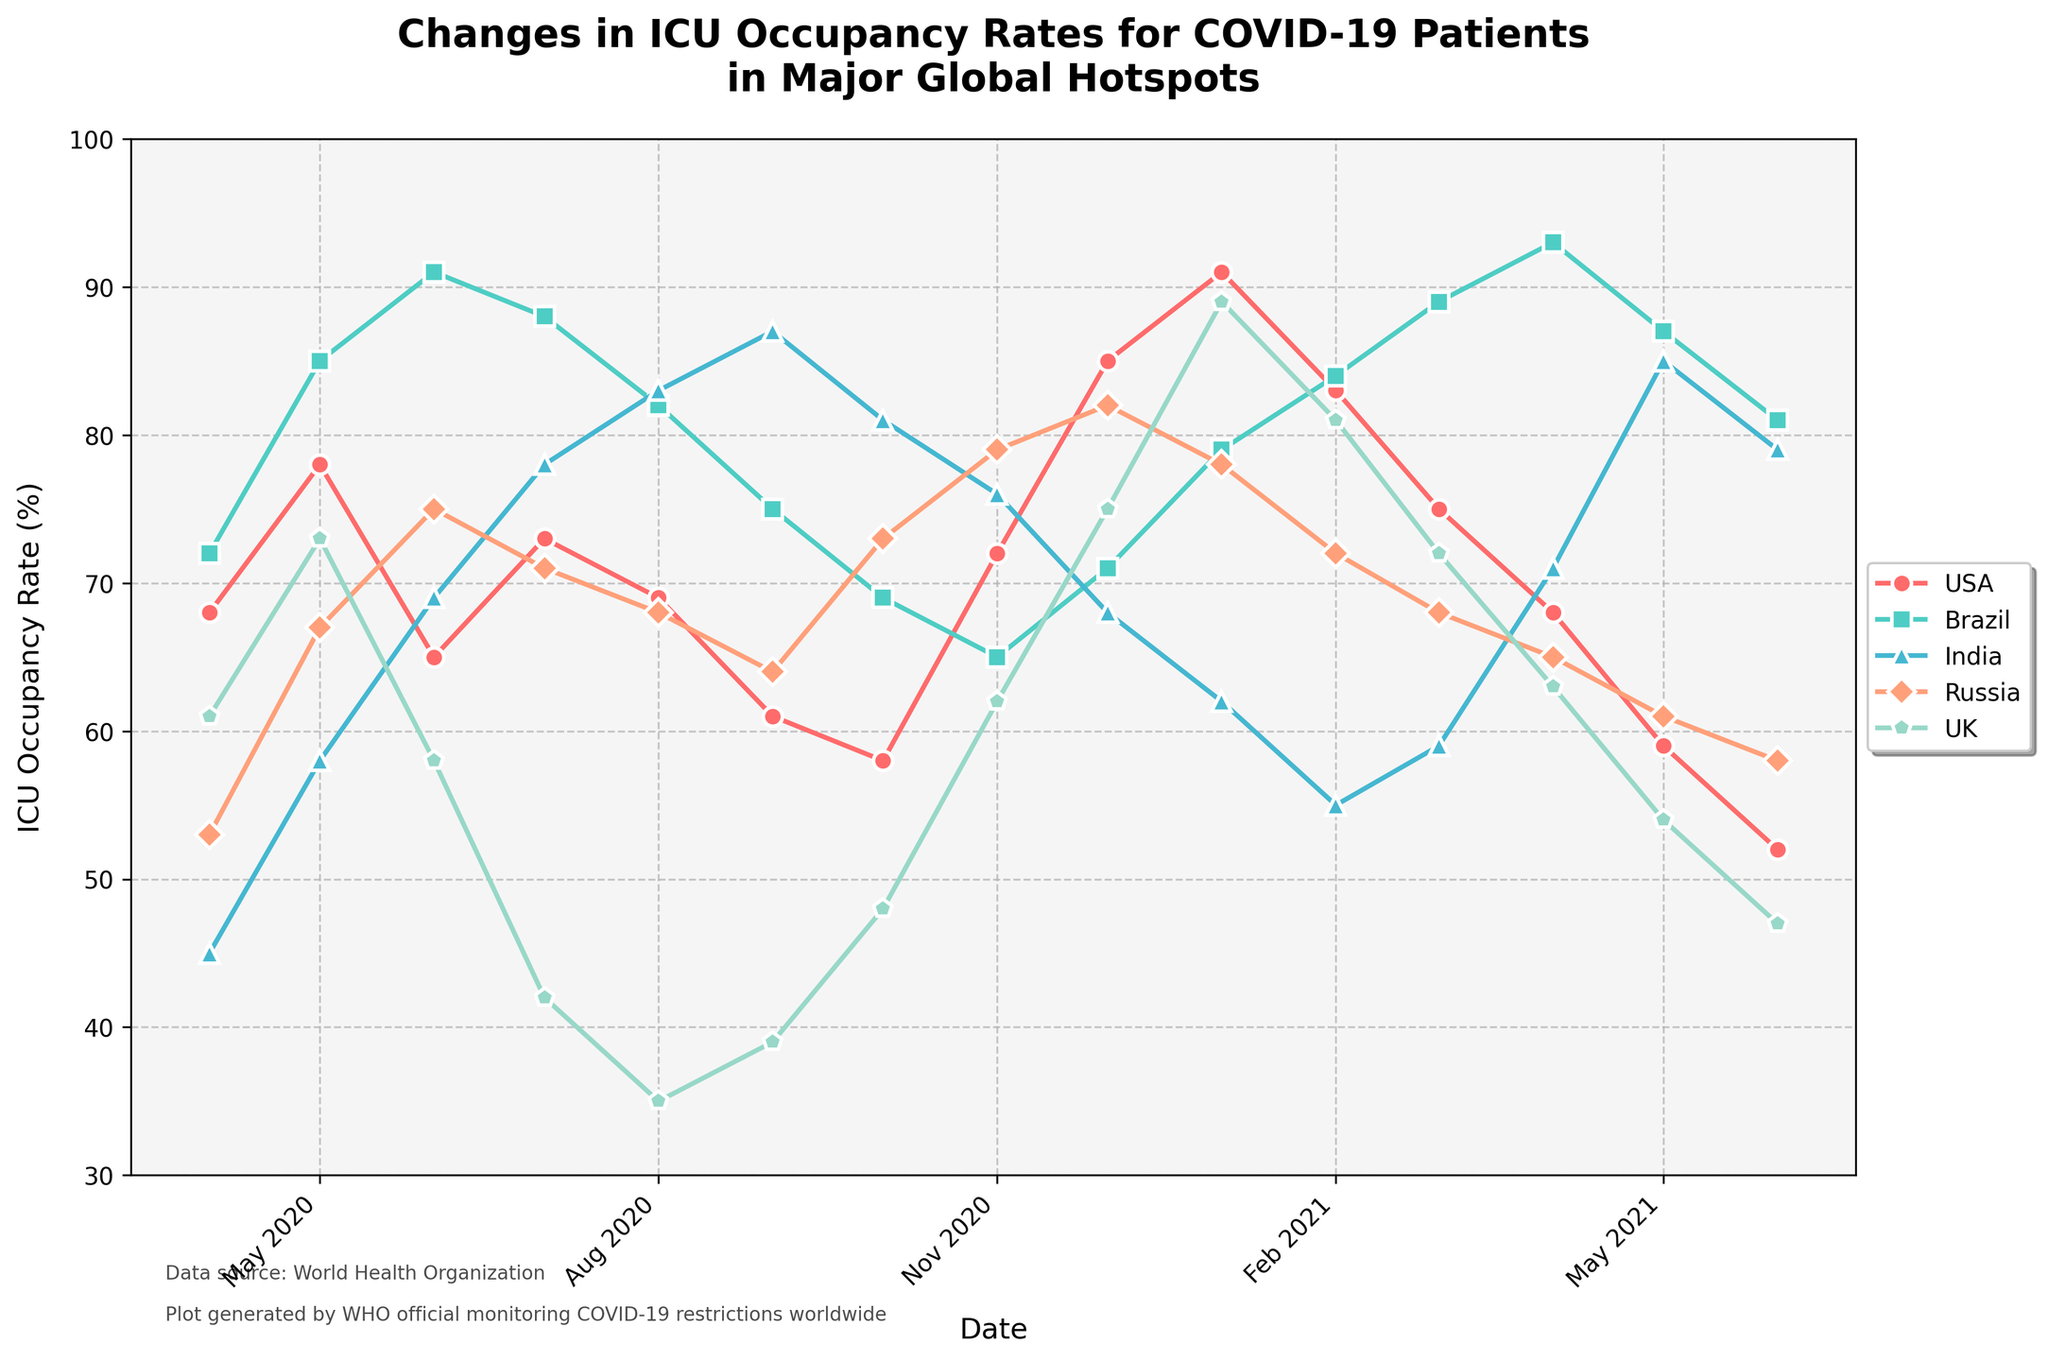Which country had the highest ICU occupancy rate in April 2020? From the figure, observe and compare the ICU occupancy rates of all countries in April 2020. Brazil has the highest value among the countries.
Answer: Brazil Which country shows the largest decrease in ICU occupancy from May 2021 to June 2021? Look at the lines and the labels for May 2021 and June 2021. Calculate the difference in ICU occupancy rate for each country and identify the largest decrease. India shows the largest drop from 85% to 79%.
Answer: India What is the trend of ICU occupancy for the USA from April 2020 to June 2021? By following the line representing the USA, observe whether the occupancy rate is generally increasing, decreasing, or fluctuating over time. The USA shows a fluctuating trend with an overall decrease.
Answer: Fluctuating and decreasing How does the ICU occupancy in the UK in January 2021 compare to that in December 2020? Look at the line representing the UK and compare the values at December 2020 and January 2021. The ICU rate in January 2021 is higher than in December 2020.
Answer: Higher Calculate the average ICU occupancy rate for Russia during the first half of 2021 (Jan-Jun). Note the values for January, February, March, April, May, and June 2021. Sum these values and divide by 6. (78 + 72 + 68 + 65 + 61 + 58) / 6 = 67
Answer: 67 Which month shows the highest ICU occupancy rate for Brazil? Find the peak point of the line representing Brazil and identify the corresponding month. April 2021 has the highest rate of Brazil at 93%.
Answer: April 2021 If you sum up the ICU occupancy rates of India for December 2020 and January 2021, what is the result? Identify the values for India in December 2020 and January 2021 and sum them. The values are 68% and 62%, respectively, so 68 + 62 = 130.
Answer: 130 Between July 2020 and September 2020, did the ICU occupancy rate in Russia increase, decrease, or stay the same? Track the line representing Russia from July to September 2020. The rate decreased from 71% to 64%.
Answer: Decrease Identify the country with the most consistent ICU occupancy trend (least variation) from April 2020 to June 2021. By observing all the lines, determine which country has the smallest fluctuations over time. The UK shows the most consistent pattern compared to others.
Answer: UK Which country's ICU occupancy rate peaked the latest during the entire period shown? Find the latest peak point among all the country lines. The UK peaked in January 2021, which is later than other peaks.
Answer: UK 